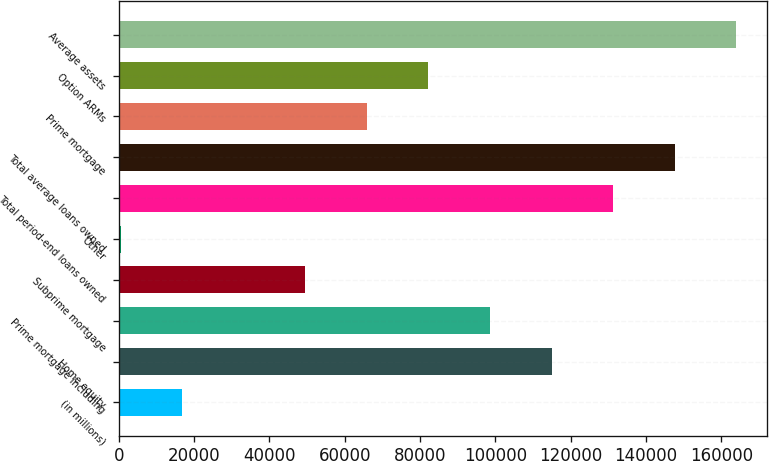<chart> <loc_0><loc_0><loc_500><loc_500><bar_chart><fcel>(in millions)<fcel>Home equity<fcel>Prime mortgage including<fcel>Subprime mortgage<fcel>Other<fcel>Total period-end loans owned<fcel>Total average loans owned<fcel>Prime mortgage<fcel>Option ARMs<fcel>Average assets<nl><fcel>16885.7<fcel>114894<fcel>98559.2<fcel>49555.1<fcel>551<fcel>131229<fcel>147563<fcel>65889.8<fcel>82224.5<fcel>163898<nl></chart> 